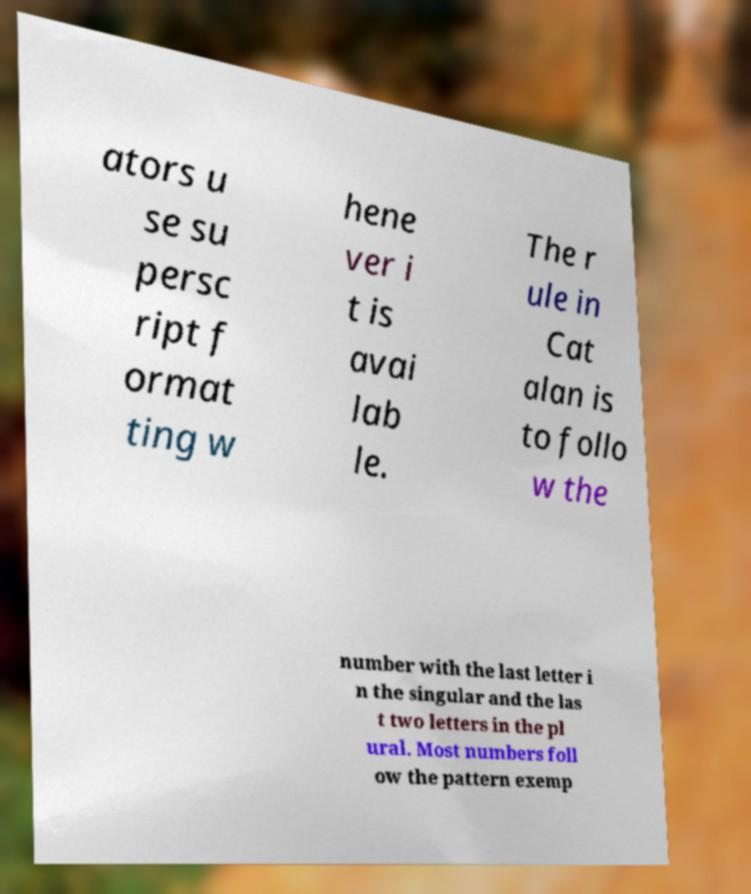There's text embedded in this image that I need extracted. Can you transcribe it verbatim? ators u se su persc ript f ormat ting w hene ver i t is avai lab le. The r ule in Cat alan is to follo w the number with the last letter i n the singular and the las t two letters in the pl ural. Most numbers foll ow the pattern exemp 